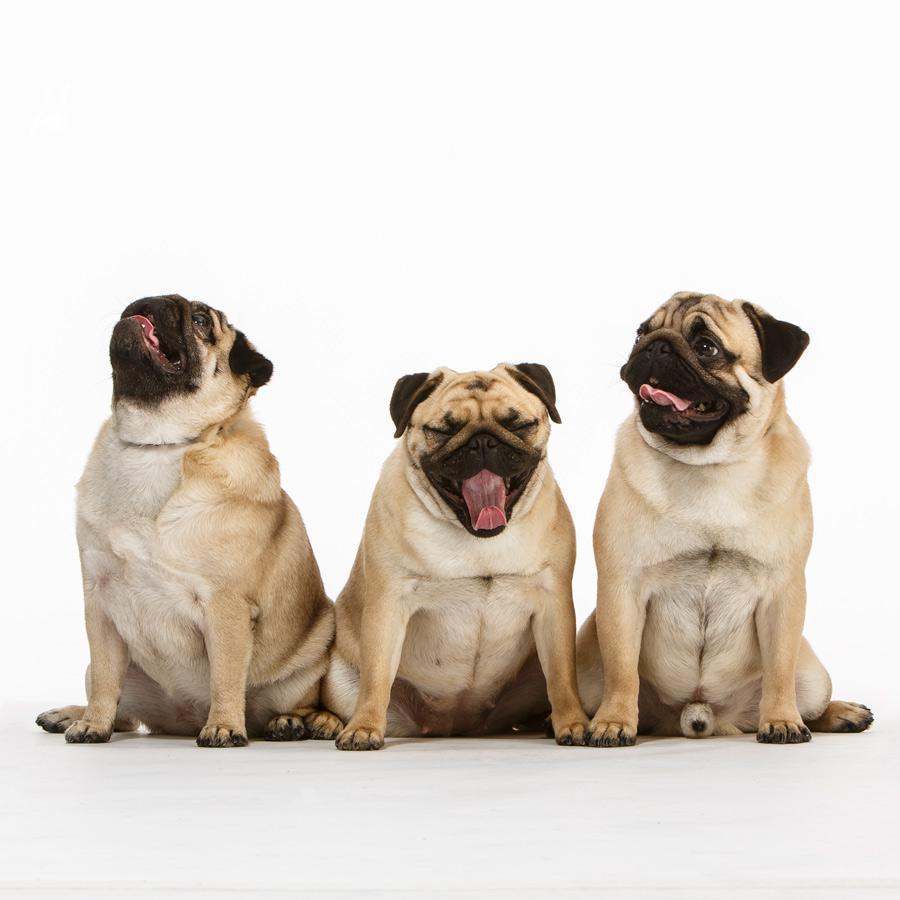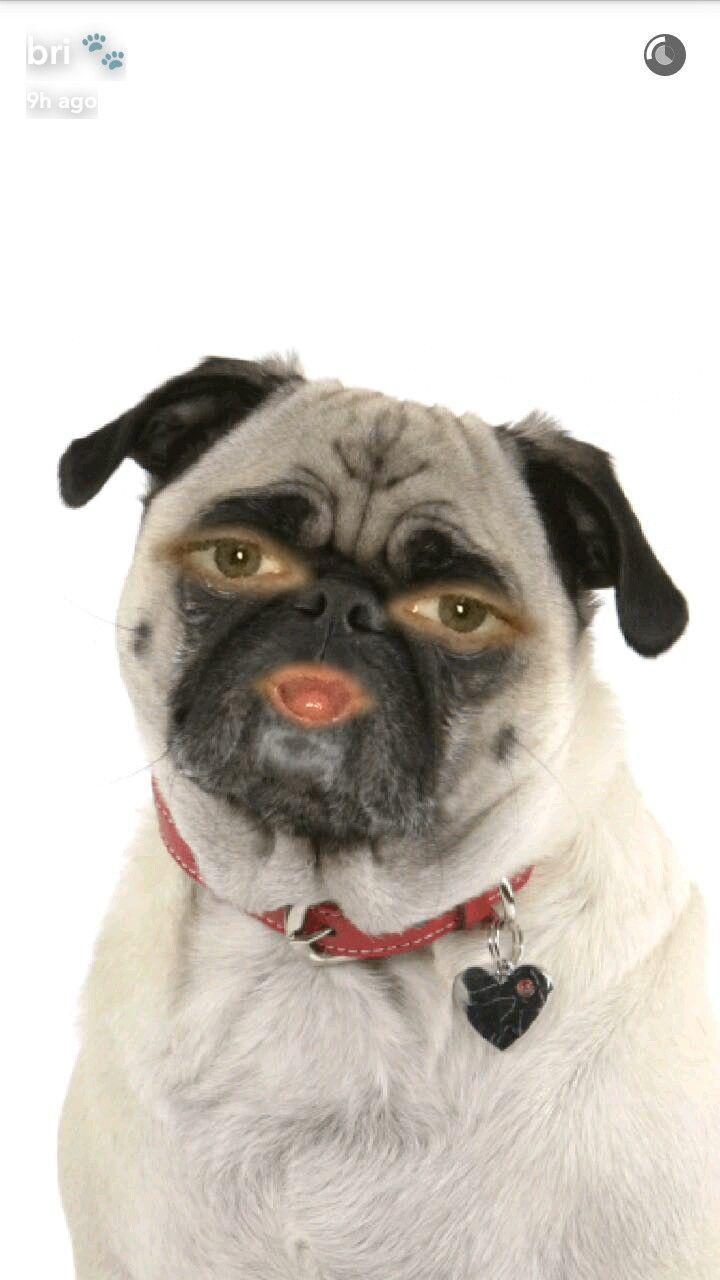The first image is the image on the left, the second image is the image on the right. For the images displayed, is the sentence "The right image contains three pug dogs." factually correct? Answer yes or no. No. The first image is the image on the left, the second image is the image on the right. For the images shown, is this caption "All dogs shown are buff-beige pugs with closed mouths, and one pug is pictured with a cake image by its face." true? Answer yes or no. No. 